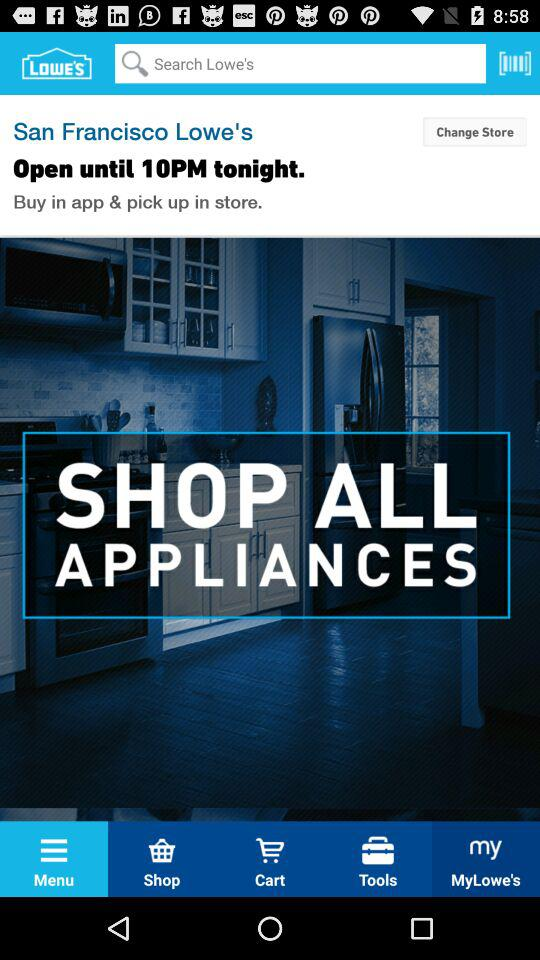What is the closing time of the shop? The closing time of the shop is 10 p.m. 